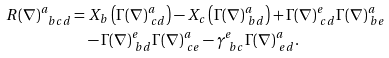<formula> <loc_0><loc_0><loc_500><loc_500>R ( \nabla ) ^ { a } _ { \ b c d } = & \ X _ { b } \left ( \Gamma ( \nabla ) ^ { a } _ { \ c d } \right ) - X _ { c } \left ( \Gamma ( \nabla ) ^ { a } _ { \ b d } \right ) + \Gamma ( \nabla ) ^ { e } _ { \ c d } \Gamma ( \nabla ) ^ { a } _ { \ b e } \\ & - \Gamma ( \nabla ) ^ { e } _ { \ b d } \Gamma ( \nabla ) ^ { a } _ { \ c e } - \gamma ^ { e } _ { \ b c } \Gamma ( \nabla ) ^ { a } _ { \ e d } .</formula> 